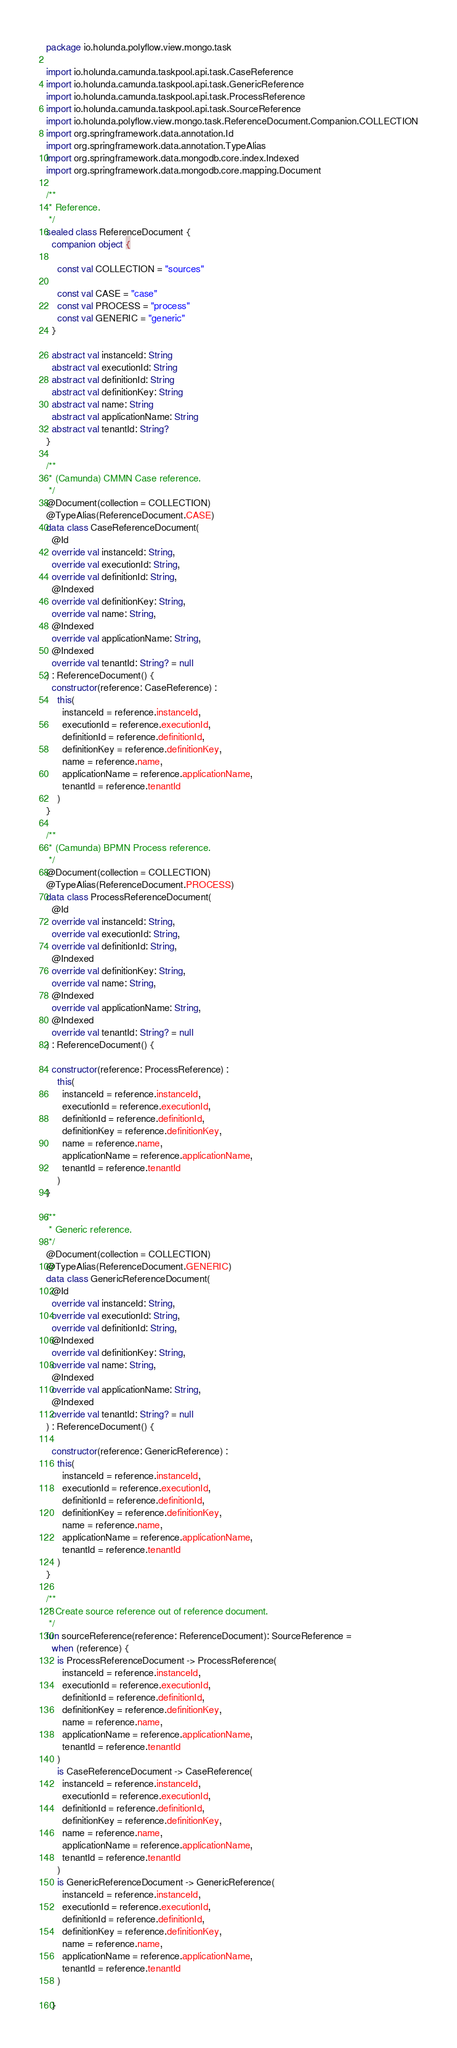<code> <loc_0><loc_0><loc_500><loc_500><_Kotlin_>package io.holunda.polyflow.view.mongo.task

import io.holunda.camunda.taskpool.api.task.CaseReference
import io.holunda.camunda.taskpool.api.task.GenericReference
import io.holunda.camunda.taskpool.api.task.ProcessReference
import io.holunda.camunda.taskpool.api.task.SourceReference
import io.holunda.polyflow.view.mongo.task.ReferenceDocument.Companion.COLLECTION
import org.springframework.data.annotation.Id
import org.springframework.data.annotation.TypeAlias
import org.springframework.data.mongodb.core.index.Indexed
import org.springframework.data.mongodb.core.mapping.Document

/**
 * Reference.
 */
sealed class ReferenceDocument {
  companion object {

    const val COLLECTION = "sources"

    const val CASE = "case"
    const val PROCESS = "process"
    const val GENERIC = "generic"
  }

  abstract val instanceId: String
  abstract val executionId: String
  abstract val definitionId: String
  abstract val definitionKey: String
  abstract val name: String
  abstract val applicationName: String
  abstract val tenantId: String?
}

/**
 * (Camunda) CMMN Case reference.
 */
@Document(collection = COLLECTION)
@TypeAlias(ReferenceDocument.CASE)
data class CaseReferenceDocument(
  @Id
  override val instanceId: String,
  override val executionId: String,
  override val definitionId: String,
  @Indexed
  override val definitionKey: String,
  override val name: String,
  @Indexed
  override val applicationName: String,
  @Indexed
  override val tenantId: String? = null
) : ReferenceDocument() {
  constructor(reference: CaseReference) :
    this(
      instanceId = reference.instanceId,
      executionId = reference.executionId,
      definitionId = reference.definitionId,
      definitionKey = reference.definitionKey,
      name = reference.name,
      applicationName = reference.applicationName,
      tenantId = reference.tenantId
    )
}

/**
 * (Camunda) BPMN Process reference.
 */
@Document(collection = COLLECTION)
@TypeAlias(ReferenceDocument.PROCESS)
data class ProcessReferenceDocument(
  @Id
  override val instanceId: String,
  override val executionId: String,
  override val definitionId: String,
  @Indexed
  override val definitionKey: String,
  override val name: String,
  @Indexed
  override val applicationName: String,
  @Indexed
  override val tenantId: String? = null
) : ReferenceDocument() {

  constructor(reference: ProcessReference) :
    this(
      instanceId = reference.instanceId,
      executionId = reference.executionId,
      definitionId = reference.definitionId,
      definitionKey = reference.definitionKey,
      name = reference.name,
      applicationName = reference.applicationName,
      tenantId = reference.tenantId
    )
}

/**
 * Generic reference.
 */
@Document(collection = COLLECTION)
@TypeAlias(ReferenceDocument.GENERIC)
data class GenericReferenceDocument(
  @Id
  override val instanceId: String,
  override val executionId: String,
  override val definitionId: String,
  @Indexed
  override val definitionKey: String,
  override val name: String,
  @Indexed
  override val applicationName: String,
  @Indexed
  override val tenantId: String? = null
) : ReferenceDocument() {

  constructor(reference: GenericReference) :
    this(
      instanceId = reference.instanceId,
      executionId = reference.executionId,
      definitionId = reference.definitionId,
      definitionKey = reference.definitionKey,
      name = reference.name,
      applicationName = reference.applicationName,
      tenantId = reference.tenantId
    )
}

/**
 * Create source reference out of reference document.
 */
fun sourceReference(reference: ReferenceDocument): SourceReference =
  when (reference) {
    is ProcessReferenceDocument -> ProcessReference(
      instanceId = reference.instanceId,
      executionId = reference.executionId,
      definitionId = reference.definitionId,
      definitionKey = reference.definitionKey,
      name = reference.name,
      applicationName = reference.applicationName,
      tenantId = reference.tenantId
    )
    is CaseReferenceDocument -> CaseReference(
      instanceId = reference.instanceId,
      executionId = reference.executionId,
      definitionId = reference.definitionId,
      definitionKey = reference.definitionKey,
      name = reference.name,
      applicationName = reference.applicationName,
      tenantId = reference.tenantId
    )
    is GenericReferenceDocument -> GenericReference(
      instanceId = reference.instanceId,
      executionId = reference.executionId,
      definitionId = reference.definitionId,
      definitionKey = reference.definitionKey,
      name = reference.name,
      applicationName = reference.applicationName,
      tenantId = reference.tenantId
    )

  }

</code> 